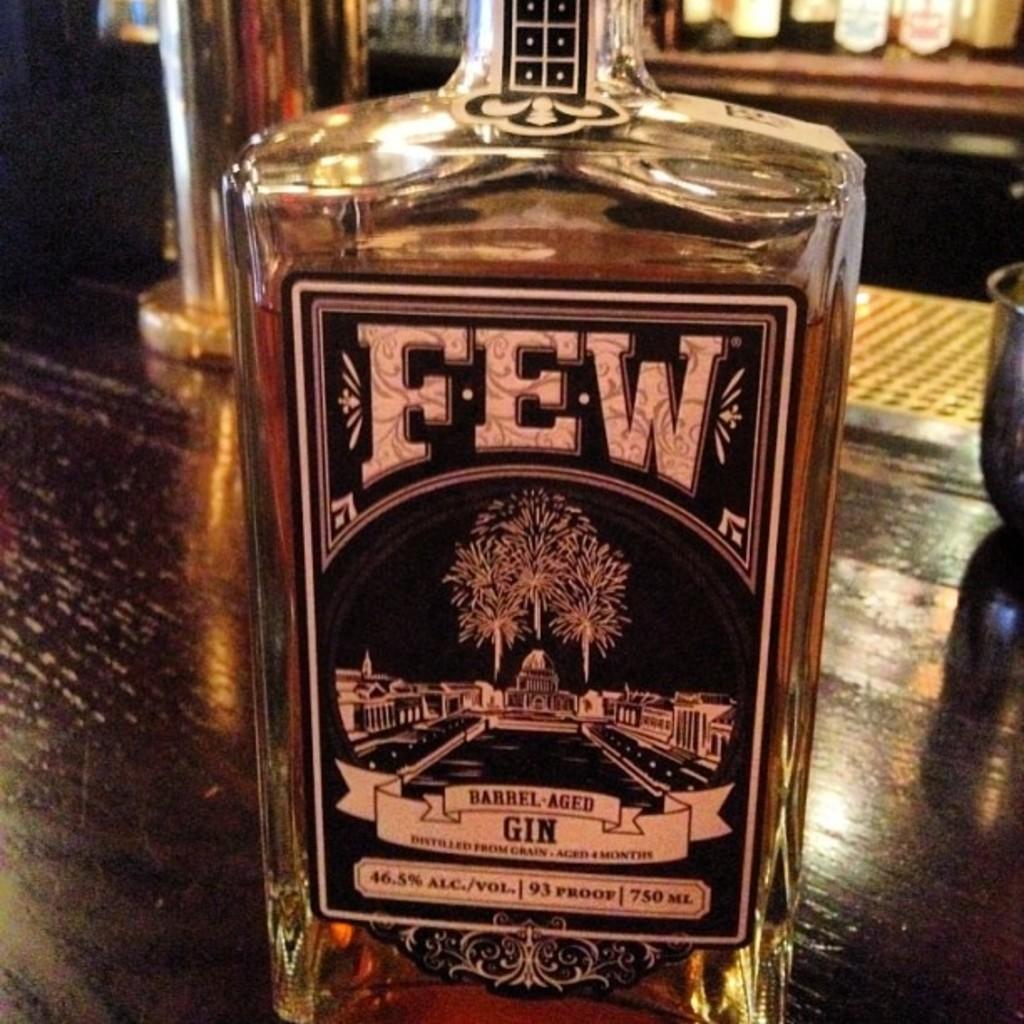What type of alcohol is shown here?
Provide a succinct answer. Gin. 